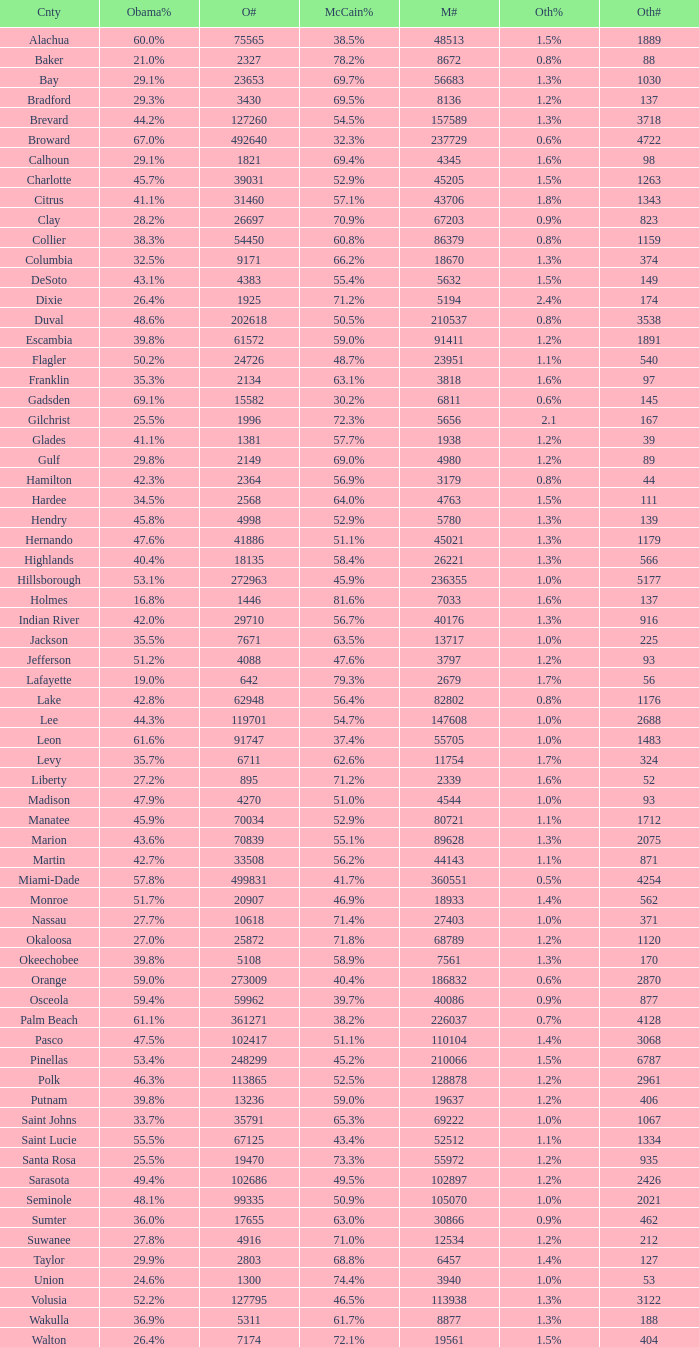How many numbers were recorded under Obama when he had 29.9% voters? 1.0. 